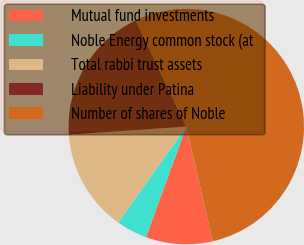<chart> <loc_0><loc_0><loc_500><loc_500><pie_chart><fcel>Mutual fund investments<fcel>Noble Energy common stock (at<fcel>Total rabbi trust assets<fcel>Liability under Patina<fcel>Number of shares of Noble<nl><fcel>9.17%<fcel>4.25%<fcel>14.09%<fcel>19.02%<fcel>53.47%<nl></chart> 